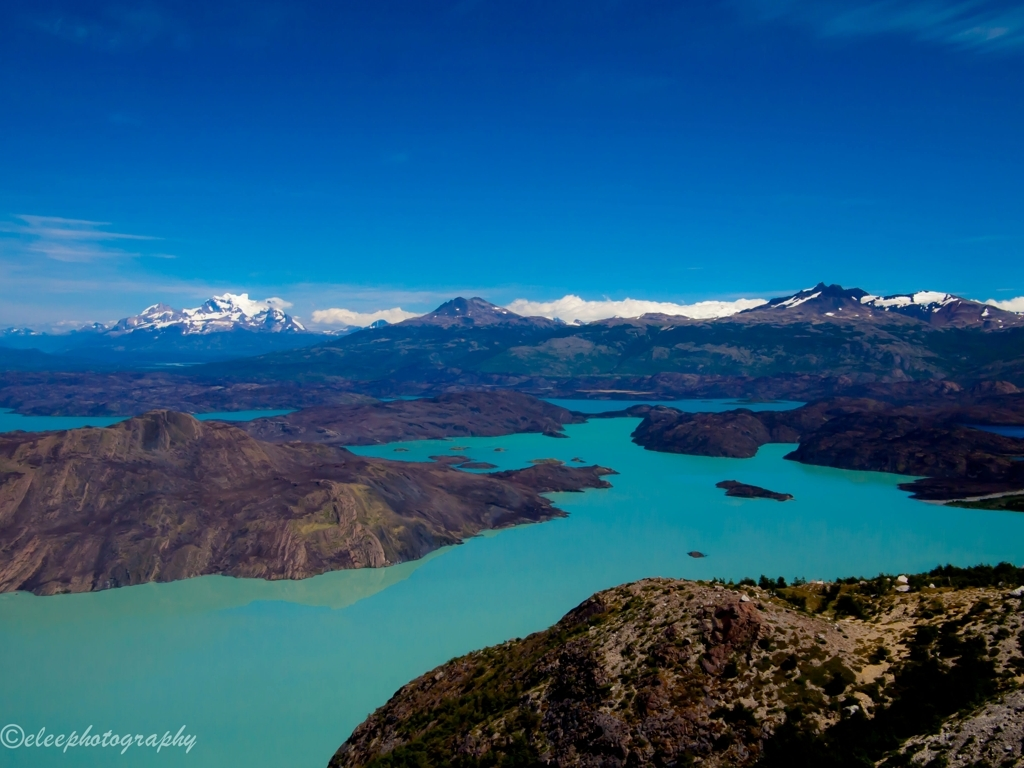What is the overall clarity of the image?
A. Poor
B. Blurry
C. Average
D. Excellent
Answer with the option's letter from the given choices directly. The overall clarity of the image is excellent. The sharpness of the landscape features, the vividness of the colors, and the distinct textures make the details stand out clearly. From the turquoise waters to the rugged terrain and snow-capped mountains in the background, every element is crisply captured. 